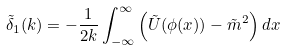<formula> <loc_0><loc_0><loc_500><loc_500>\tilde { \delta } _ { 1 } ( k ) = - \frac { 1 } { 2 k } \int _ { - \infty } ^ { \infty } \left ( \tilde { U } ( \phi ( x ) ) - \tilde { m } ^ { 2 } \right ) d x</formula> 